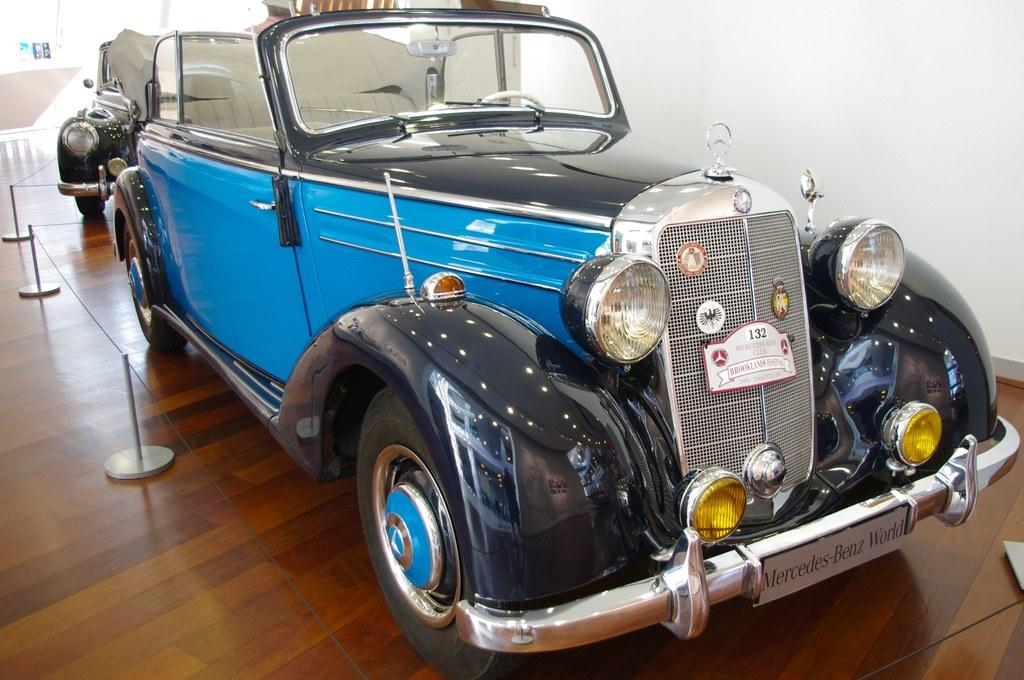What are the main subjects in the center of the image? There are two cars in the center of the image. What other objects can be seen in the image? There are some poles visible in the image. What is the surface on which the cars are placed? There is a floor visible at the bottom of the image. What can be seen in the background of the image? There is a wall and a railing in the background of the image. How many cows are grazing on the roof in the image? There are no cows or roofs present in the image. 